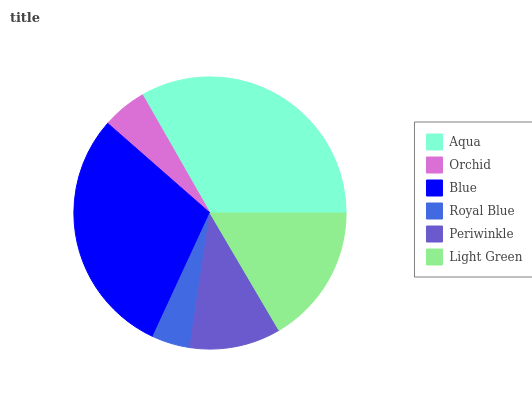Is Royal Blue the minimum?
Answer yes or no. Yes. Is Aqua the maximum?
Answer yes or no. Yes. Is Orchid the minimum?
Answer yes or no. No. Is Orchid the maximum?
Answer yes or no. No. Is Aqua greater than Orchid?
Answer yes or no. Yes. Is Orchid less than Aqua?
Answer yes or no. Yes. Is Orchid greater than Aqua?
Answer yes or no. No. Is Aqua less than Orchid?
Answer yes or no. No. Is Light Green the high median?
Answer yes or no. Yes. Is Periwinkle the low median?
Answer yes or no. Yes. Is Orchid the high median?
Answer yes or no. No. Is Blue the low median?
Answer yes or no. No. 